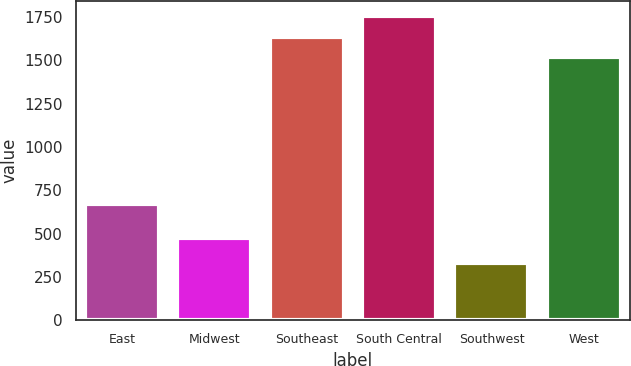Convert chart to OTSL. <chart><loc_0><loc_0><loc_500><loc_500><bar_chart><fcel>East<fcel>Midwest<fcel>Southeast<fcel>South Central<fcel>Southwest<fcel>West<nl><fcel>667.8<fcel>471.3<fcel>1636.11<fcel>1755.42<fcel>327.7<fcel>1516.8<nl></chart> 